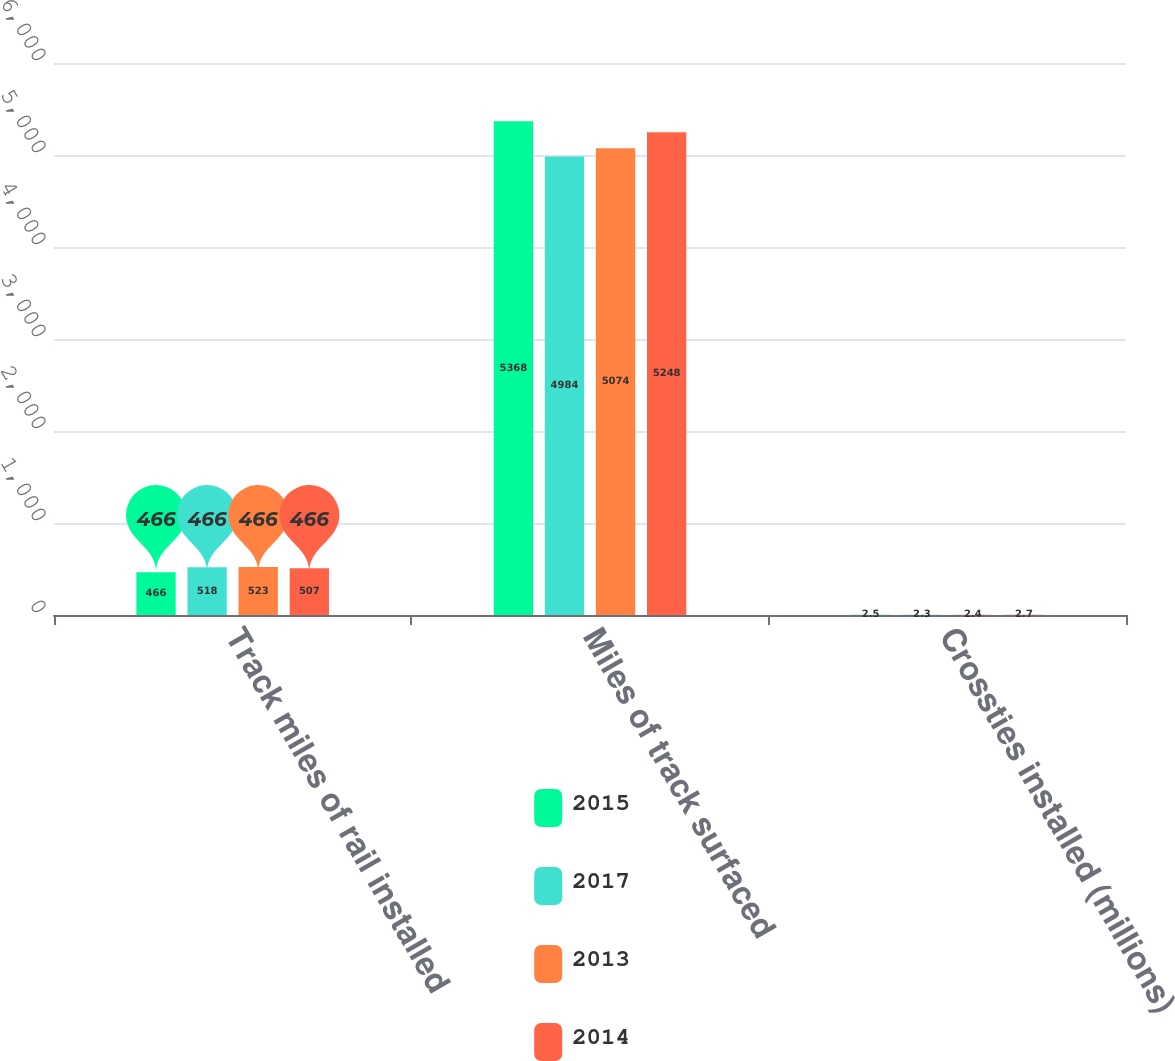<chart> <loc_0><loc_0><loc_500><loc_500><stacked_bar_chart><ecel><fcel>Track miles of rail installed<fcel>Miles of track surfaced<fcel>Crossties installed (millions)<nl><fcel>2015<fcel>466<fcel>5368<fcel>2.5<nl><fcel>2017<fcel>518<fcel>4984<fcel>2.3<nl><fcel>2013<fcel>523<fcel>5074<fcel>2.4<nl><fcel>2014<fcel>507<fcel>5248<fcel>2.7<nl></chart> 